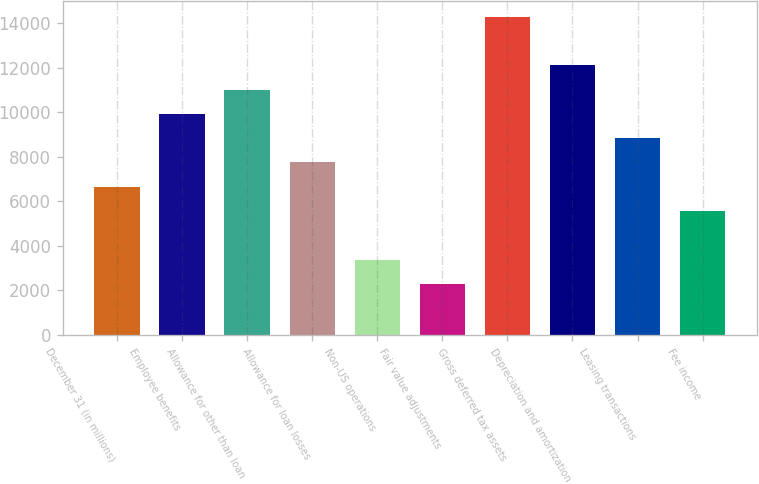Convert chart to OTSL. <chart><loc_0><loc_0><loc_500><loc_500><bar_chart><fcel>December 31 (in millions)<fcel>Employee benefits<fcel>Allowance for other than loan<fcel>Allowance for loan losses<fcel>Non-US operations<fcel>Fair value adjustments<fcel>Gross deferred tax assets<fcel>Depreciation and amortization<fcel>Leasing transactions<fcel>Fee income<nl><fcel>6654.8<fcel>9927.2<fcel>11018<fcel>7745.6<fcel>3382.4<fcel>2291.6<fcel>14290.4<fcel>12108.8<fcel>8836.4<fcel>5564<nl></chart> 